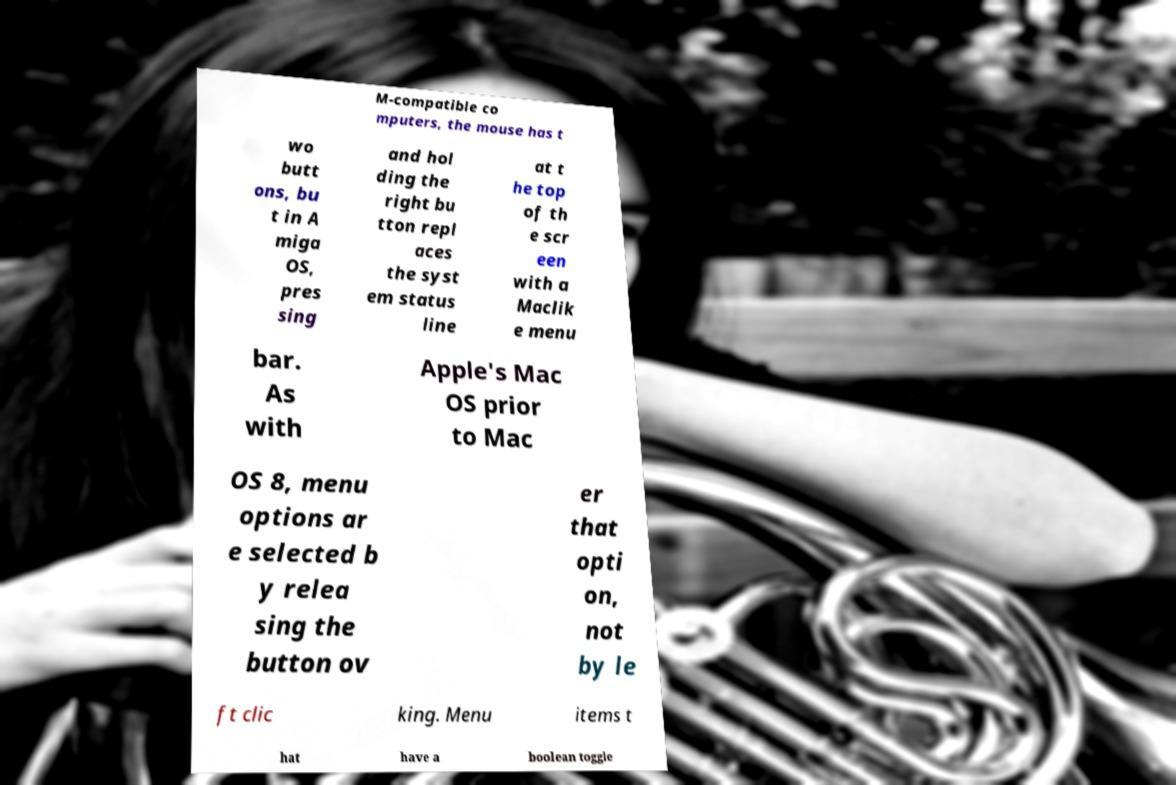For documentation purposes, I need the text within this image transcribed. Could you provide that? M-compatible co mputers, the mouse has t wo butt ons, bu t in A miga OS, pres sing and hol ding the right bu tton repl aces the syst em status line at t he top of th e scr een with a Maclik e menu bar. As with Apple's Mac OS prior to Mac OS 8, menu options ar e selected b y relea sing the button ov er that opti on, not by le ft clic king. Menu items t hat have a boolean toggle 